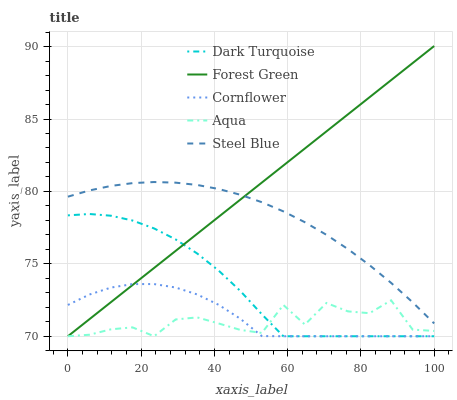Does Aqua have the minimum area under the curve?
Answer yes or no. Yes. Does Forest Green have the maximum area under the curve?
Answer yes or no. Yes. Does Forest Green have the minimum area under the curve?
Answer yes or no. No. Does Aqua have the maximum area under the curve?
Answer yes or no. No. Is Forest Green the smoothest?
Answer yes or no. Yes. Is Aqua the roughest?
Answer yes or no. Yes. Is Aqua the smoothest?
Answer yes or no. No. Is Forest Green the roughest?
Answer yes or no. No. Does Dark Turquoise have the lowest value?
Answer yes or no. Yes. Does Steel Blue have the lowest value?
Answer yes or no. No. Does Forest Green have the highest value?
Answer yes or no. Yes. Does Aqua have the highest value?
Answer yes or no. No. Is Dark Turquoise less than Steel Blue?
Answer yes or no. Yes. Is Steel Blue greater than Dark Turquoise?
Answer yes or no. Yes. Does Forest Green intersect Dark Turquoise?
Answer yes or no. Yes. Is Forest Green less than Dark Turquoise?
Answer yes or no. No. Is Forest Green greater than Dark Turquoise?
Answer yes or no. No. Does Dark Turquoise intersect Steel Blue?
Answer yes or no. No. 